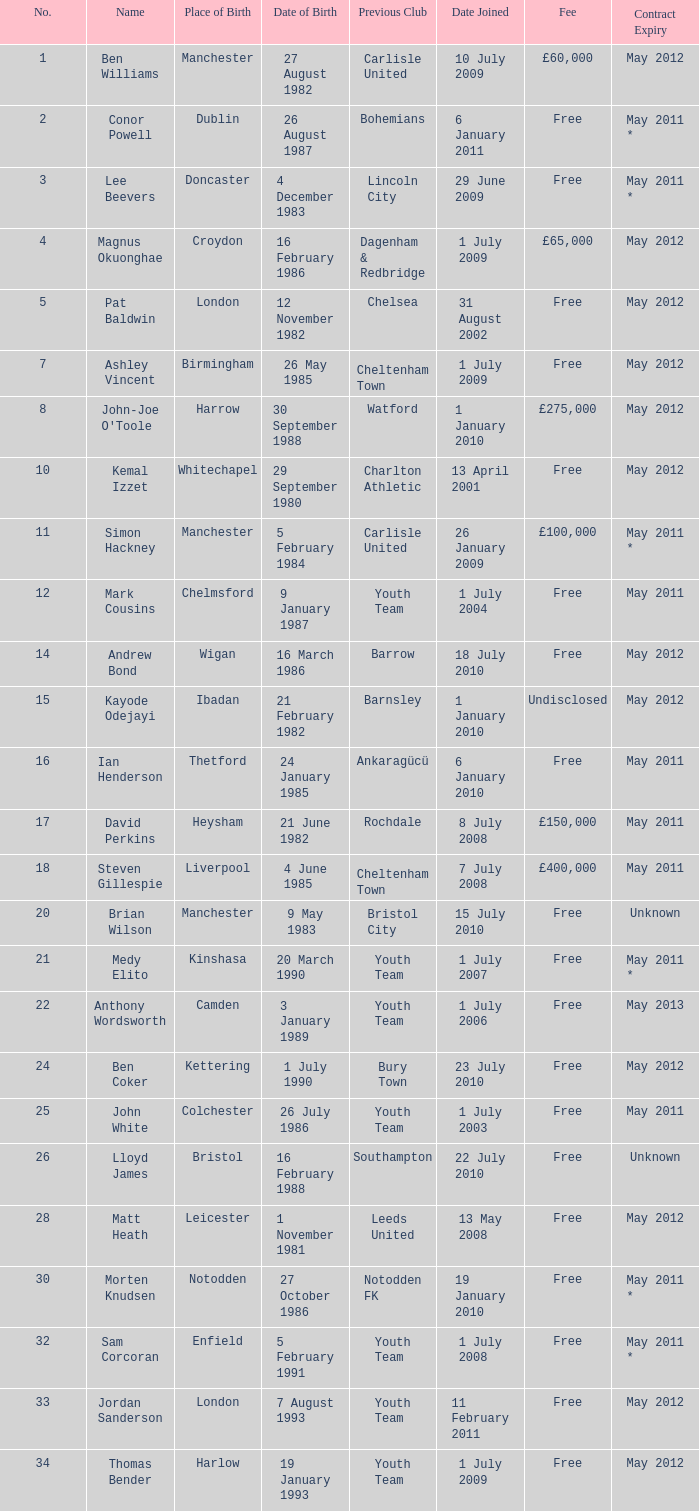Prior to his current team, where did ben williams belong in terms of clubs? Carlisle United. 